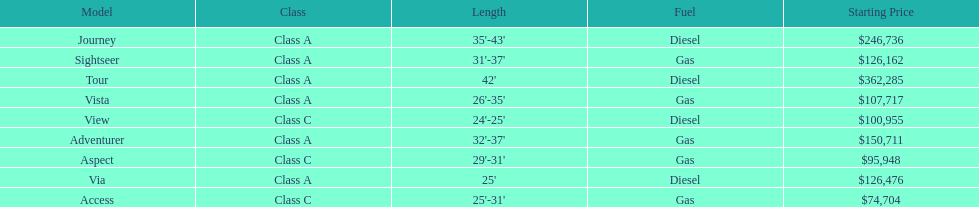Does the tour operate on diesel or gas? Diesel. 